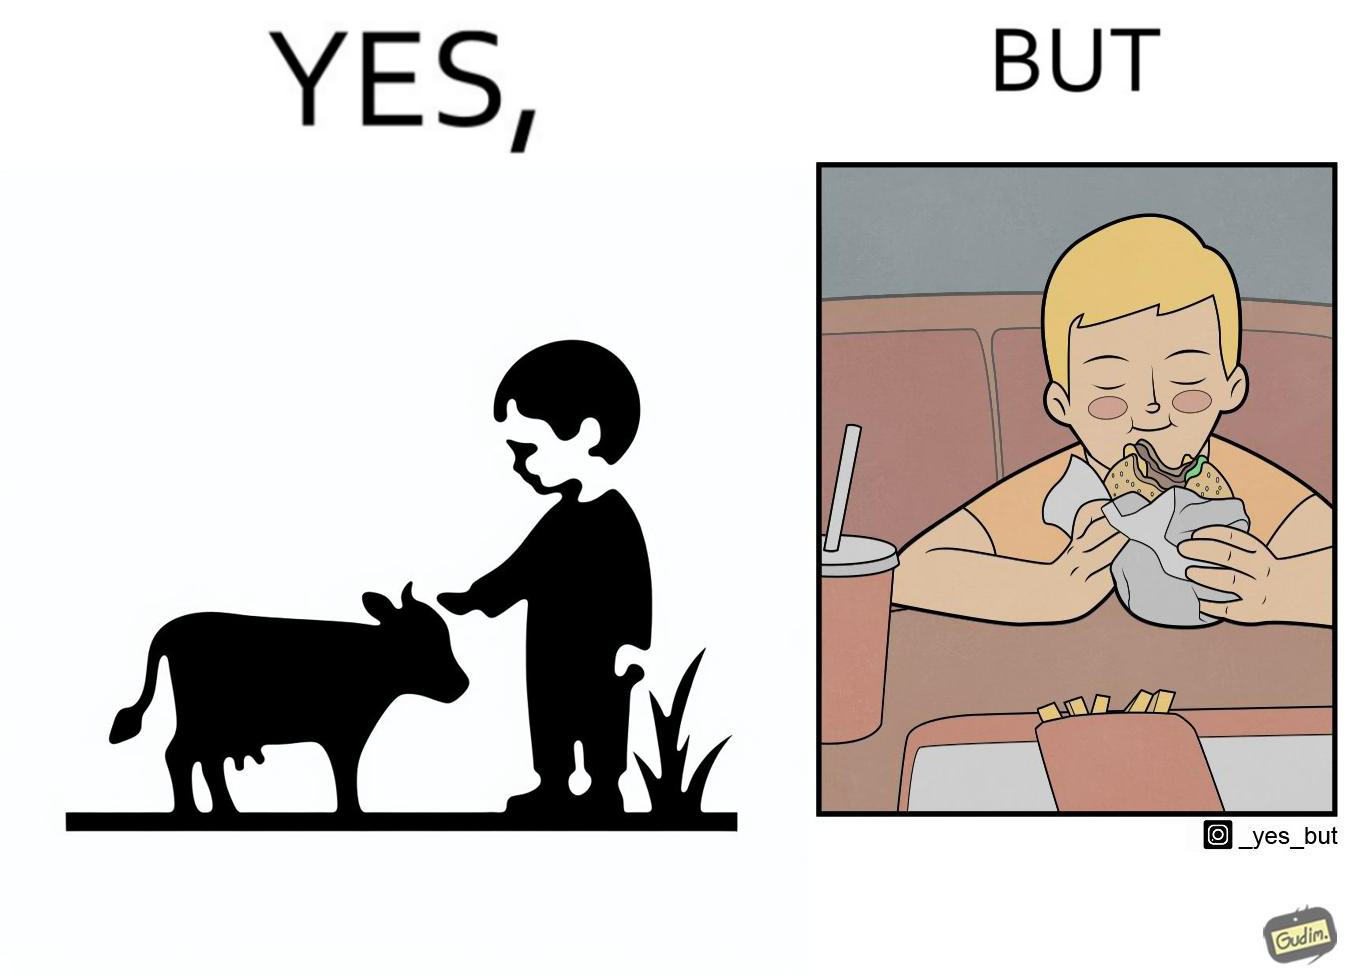What makes this image funny or satirical? The irony is that the boy is petting the cow to show that he cares about the animal, but then he also eats hamburgers made from the same cows 